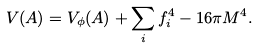<formula> <loc_0><loc_0><loc_500><loc_500>V ( A ) = V _ { \phi } ( A ) + \sum _ { i } f _ { i } ^ { 4 } - 1 6 \pi M ^ { 4 } .</formula> 